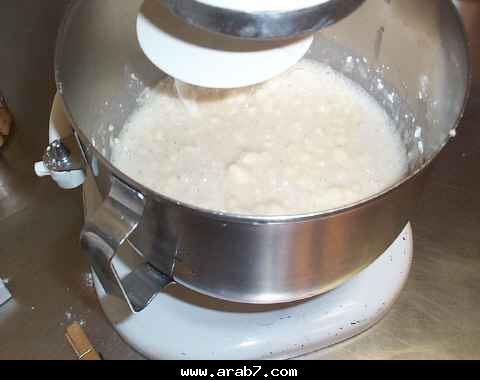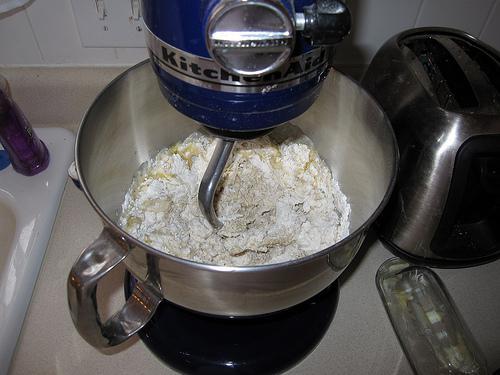The first image is the image on the left, the second image is the image on the right. Considering the images on both sides, is "The images show two different stages of dough in a mixer." valid? Answer yes or no. Yes. 